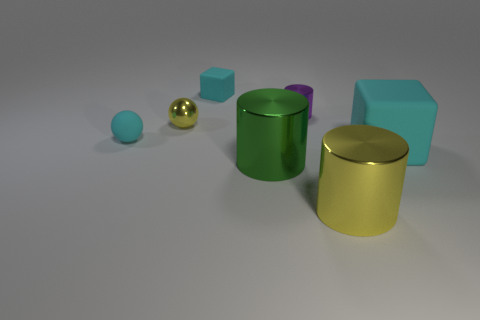Subtract all tiny metallic cylinders. How many cylinders are left? 2 Subtract all purple cylinders. How many cylinders are left? 2 Add 2 big yellow metallic cylinders. How many objects exist? 9 Subtract all cylinders. How many objects are left? 4 Subtract all gray balls. Subtract all brown cubes. How many balls are left? 2 Subtract all green cubes. How many purple cylinders are left? 1 Subtract all small purple things. Subtract all green rubber balls. How many objects are left? 6 Add 7 small yellow metallic objects. How many small yellow metallic objects are left? 8 Add 5 yellow shiny objects. How many yellow shiny objects exist? 7 Subtract 0 gray cubes. How many objects are left? 7 